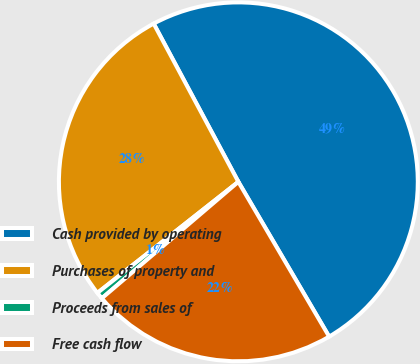Convert chart to OTSL. <chart><loc_0><loc_0><loc_500><loc_500><pie_chart><fcel>Cash provided by operating<fcel>Purchases of property and<fcel>Proceeds from sales of<fcel>Free cash flow<nl><fcel>49.38%<fcel>27.8%<fcel>0.62%<fcel>22.2%<nl></chart> 